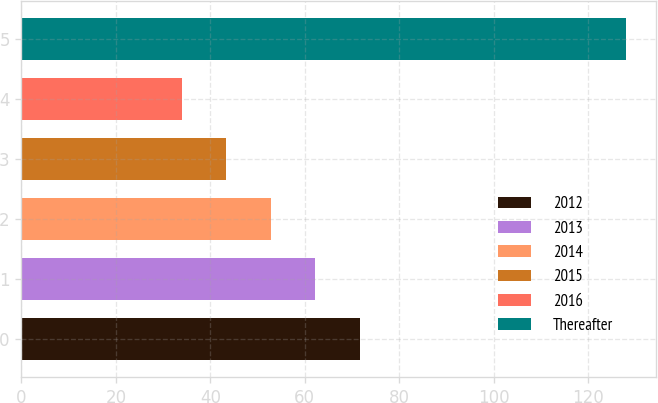Convert chart. <chart><loc_0><loc_0><loc_500><loc_500><bar_chart><fcel>2012<fcel>2013<fcel>2014<fcel>2015<fcel>2016<fcel>Thereafter<nl><fcel>71.6<fcel>62.2<fcel>52.8<fcel>43.4<fcel>34<fcel>128<nl></chart> 